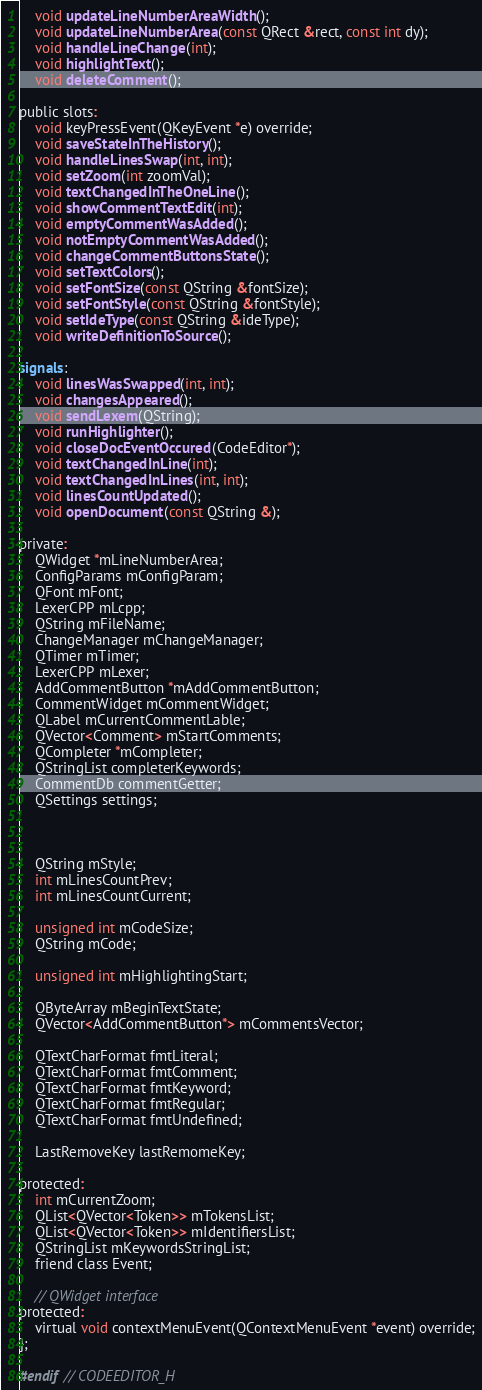Convert code to text. <code><loc_0><loc_0><loc_500><loc_500><_C_>    void updateLineNumberAreaWidth();
    void updateLineNumberArea(const QRect &rect, const int dy);
    void handleLineChange(int);
    void highlightText();
    void deleteComment();

public slots:
    void keyPressEvent(QKeyEvent *e) override;
    void saveStateInTheHistory();
    void handleLinesSwap(int, int);
    void setZoom(int zoomVal);
    void textChangedInTheOneLine();
    void showCommentTextEdit(int);
    void emptyCommentWasAdded();
    void notEmptyCommentWasAdded();
    void changeCommentButtonsState();
    void setTextColors();
    void setFontSize(const QString &fontSize);
    void setFontStyle(const QString &fontStyle);
    void setIdeType(const QString &ideType);
    void writeDefinitionToSource();

signals:
    void linesWasSwapped(int, int);
    void changesAppeared();
    void sendLexem(QString);
    void runHighlighter();
    void closeDocEventOccured(CodeEditor*);
    void textChangedInLine(int);
    void textChangedInLines(int, int);
    void linesCountUpdated();
    void openDocument(const QString &);

private:
    QWidget *mLineNumberArea;
    ConfigParams mConfigParam;
    QFont mFont;
    LexerCPP mLcpp;
    QString mFileName;
    ChangeManager mChangeManager;
    QTimer mTimer;
    LexerCPP mLexer;
    AddCommentButton *mAddCommentButton;
    CommentWidget mCommentWidget;
    QLabel mCurrentCommentLable;
    QVector<Comment> mStartComments;
    QCompleter *mCompleter;
    QStringList completerKeywords;
    CommentDb commentGetter;
    QSettings settings;



    QString mStyle;
    int mLinesCountPrev;
    int mLinesCountCurrent;

    unsigned int mCodeSize;
    QString mCode;

    unsigned int mHighlightingStart;

    QByteArray mBeginTextState;
    QVector<AddCommentButton*> mCommentsVector;

    QTextCharFormat fmtLiteral;
    QTextCharFormat fmtComment;
    QTextCharFormat fmtKeyword;
    QTextCharFormat fmtRegular;
    QTextCharFormat fmtUndefined;

    LastRemoveKey lastRemomeKey;

protected:
    int mCurrentZoom;
    QList<QVector<Token>> mTokensList;
    QList<QVector<Token>> mIdentifiersList;
    QStringList mKeywordsStringList;
    friend class Event;

    // QWidget interface
protected:
    virtual void contextMenuEvent(QContextMenuEvent *event) override;
};

#endif // CODEEDITOR_H
</code> 